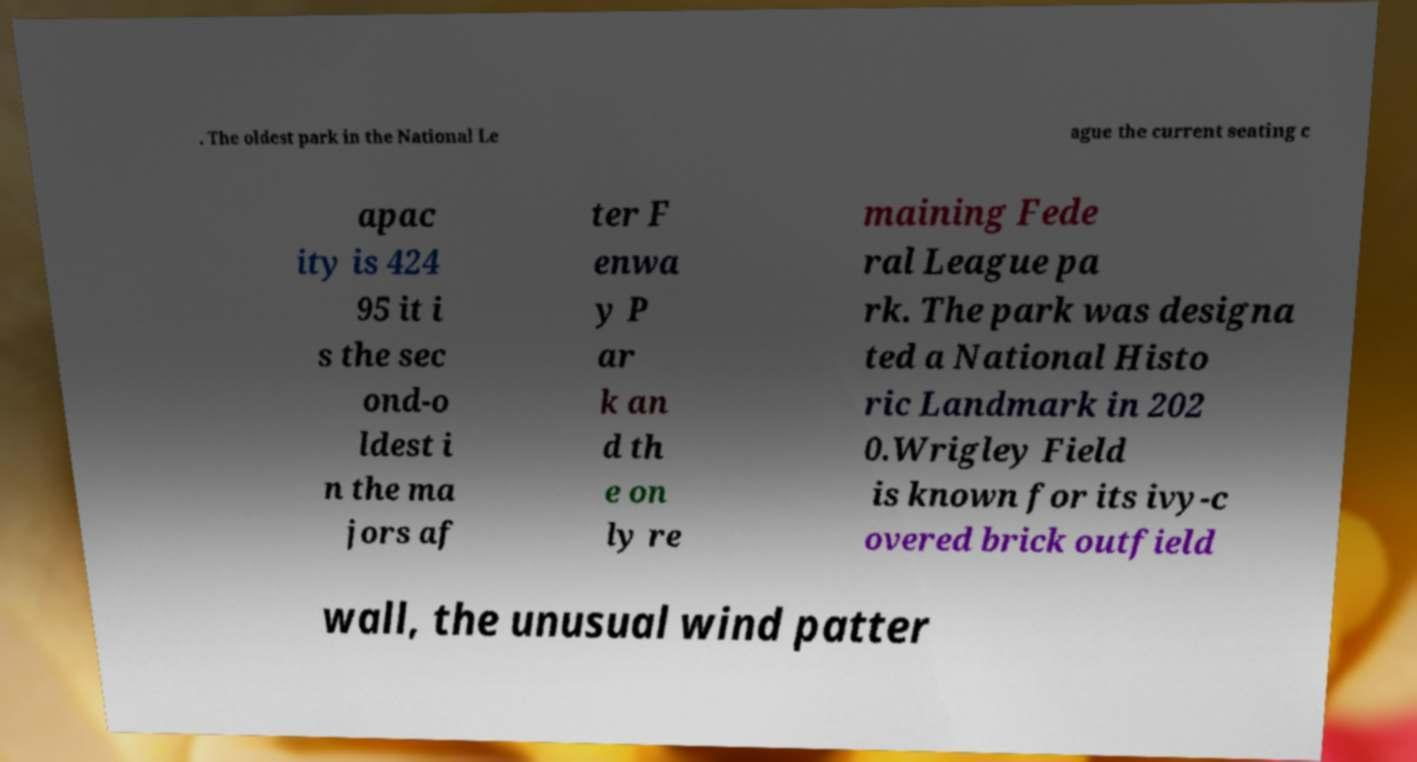Please read and relay the text visible in this image. What does it say? . The oldest park in the National Le ague the current seating c apac ity is 424 95 it i s the sec ond-o ldest i n the ma jors af ter F enwa y P ar k an d th e on ly re maining Fede ral League pa rk. The park was designa ted a National Histo ric Landmark in 202 0.Wrigley Field is known for its ivy-c overed brick outfield wall, the unusual wind patter 